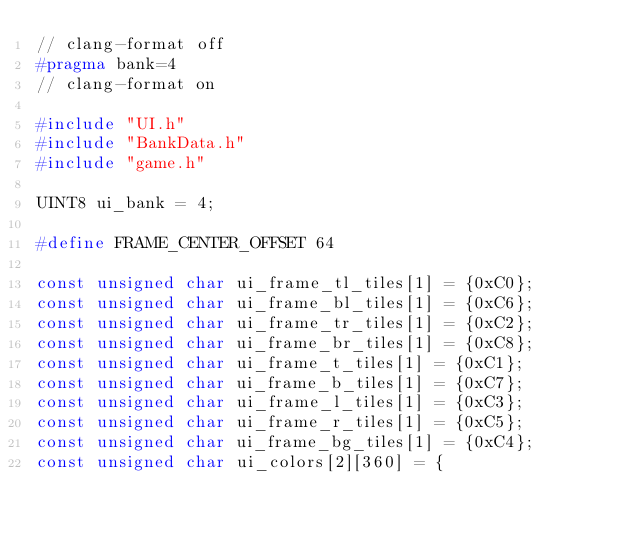Convert code to text. <code><loc_0><loc_0><loc_500><loc_500><_C_>// clang-format off
#pragma bank=4
// clang-format on

#include "UI.h"
#include "BankData.h"
#include "game.h"

UINT8 ui_bank = 4;

#define FRAME_CENTER_OFFSET 64

const unsigned char ui_frame_tl_tiles[1] = {0xC0};
const unsigned char ui_frame_bl_tiles[1] = {0xC6};
const unsigned char ui_frame_tr_tiles[1] = {0xC2};
const unsigned char ui_frame_br_tiles[1] = {0xC8};
const unsigned char ui_frame_t_tiles[1] = {0xC1};
const unsigned char ui_frame_b_tiles[1] = {0xC7};
const unsigned char ui_frame_l_tiles[1] = {0xC3};
const unsigned char ui_frame_r_tiles[1] = {0xC5};
const unsigned char ui_frame_bg_tiles[1] = {0xC4};
const unsigned char ui_colors[2][360] = {</code> 